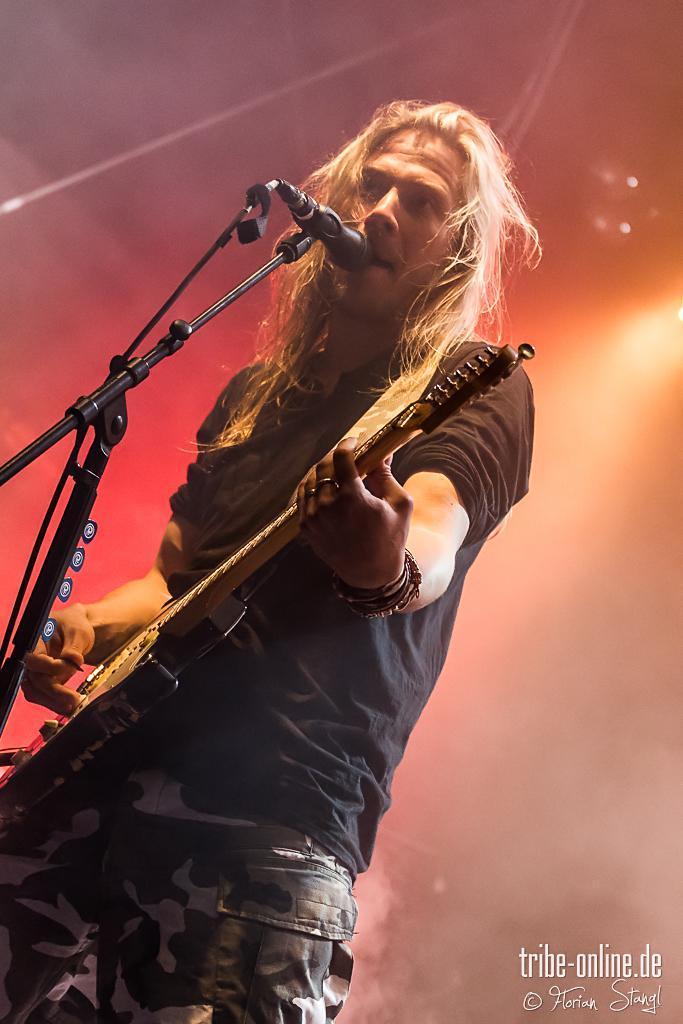Describe this image in one or two sentences. In this image i can see a person holding a guitar,in front of him there is a mike. Back side of him there is a light visible and there is a some text written on the image on the right side corner. 